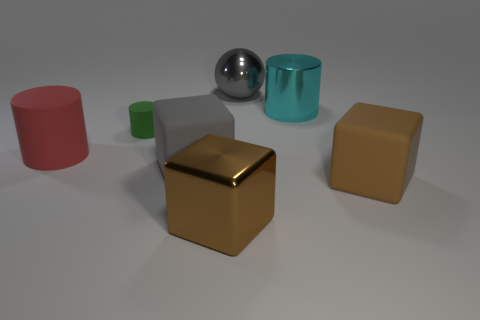There is a green cylinder that is to the left of the brown block that is on the left side of the large shiny sphere; how big is it?
Give a very brief answer. Small. What is the color of the metal thing that is in front of the shiny ball and behind the big metallic block?
Ensure brevity in your answer.  Cyan. What material is the cyan thing that is the same size as the gray metal sphere?
Keep it short and to the point. Metal. What number of other things are made of the same material as the large gray sphere?
Your answer should be compact. 2. Does the metal thing in front of the big red matte cylinder have the same color as the rubber block to the right of the gray metallic object?
Your answer should be compact. Yes. There is a large gray shiny object right of the big gray object in front of the green matte thing; what shape is it?
Your answer should be compact. Sphere. How many other things are the same color as the ball?
Ensure brevity in your answer.  1. Is the material of the brown object that is left of the large cyan metallic cylinder the same as the big brown block that is on the right side of the brown metal cube?
Offer a very short reply. No. There is a cube that is on the right side of the brown shiny block; how big is it?
Keep it short and to the point. Large. What is the material of the large cyan thing that is the same shape as the large red thing?
Your answer should be compact. Metal. 